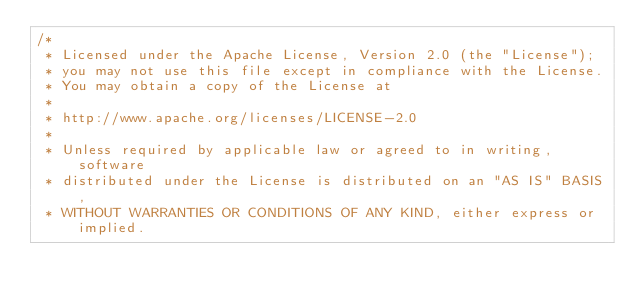Convert code to text. <code><loc_0><loc_0><loc_500><loc_500><_JavaScript_>/*
 * Licensed under the Apache License, Version 2.0 (the "License");
 * you may not use this file except in compliance with the License.
 * You may obtain a copy of the License at
 *
 * http://www.apache.org/licenses/LICENSE-2.0
 *
 * Unless required by applicable law or agreed to in writing, software
 * distributed under the License is distributed on an "AS IS" BASIS,
 * WITHOUT WARRANTIES OR CONDITIONS OF ANY KIND, either express or implied.</code> 